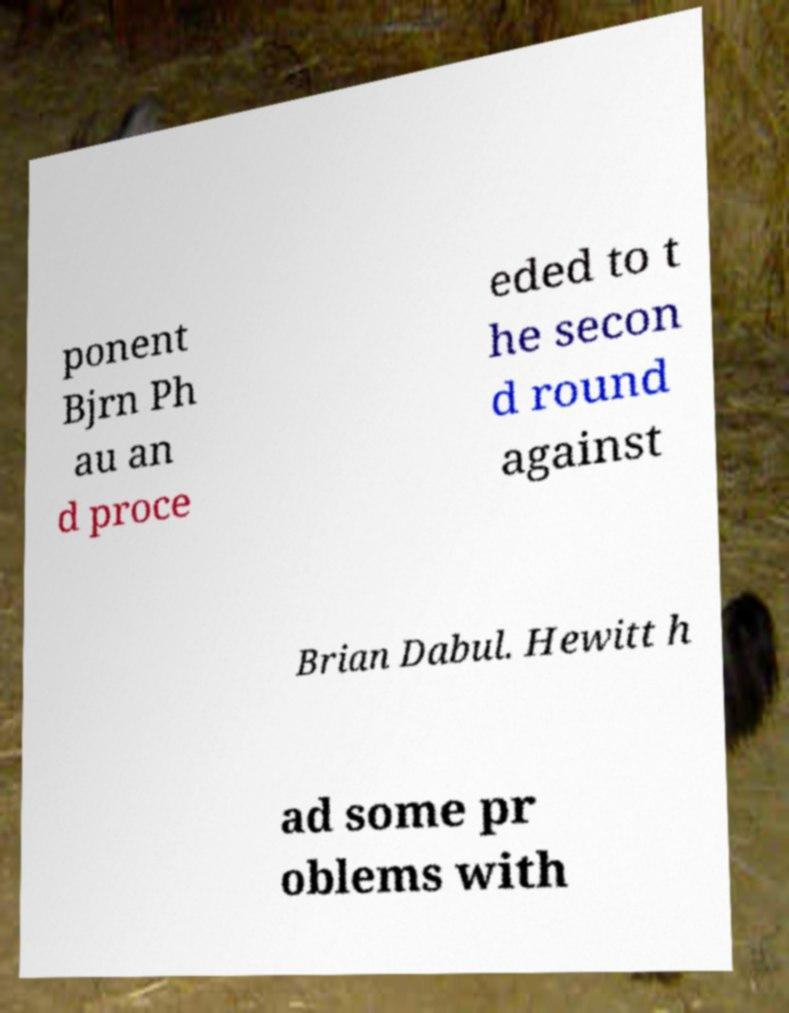Please read and relay the text visible in this image. What does it say? ponent Bjrn Ph au an d proce eded to t he secon d round against Brian Dabul. Hewitt h ad some pr oblems with 